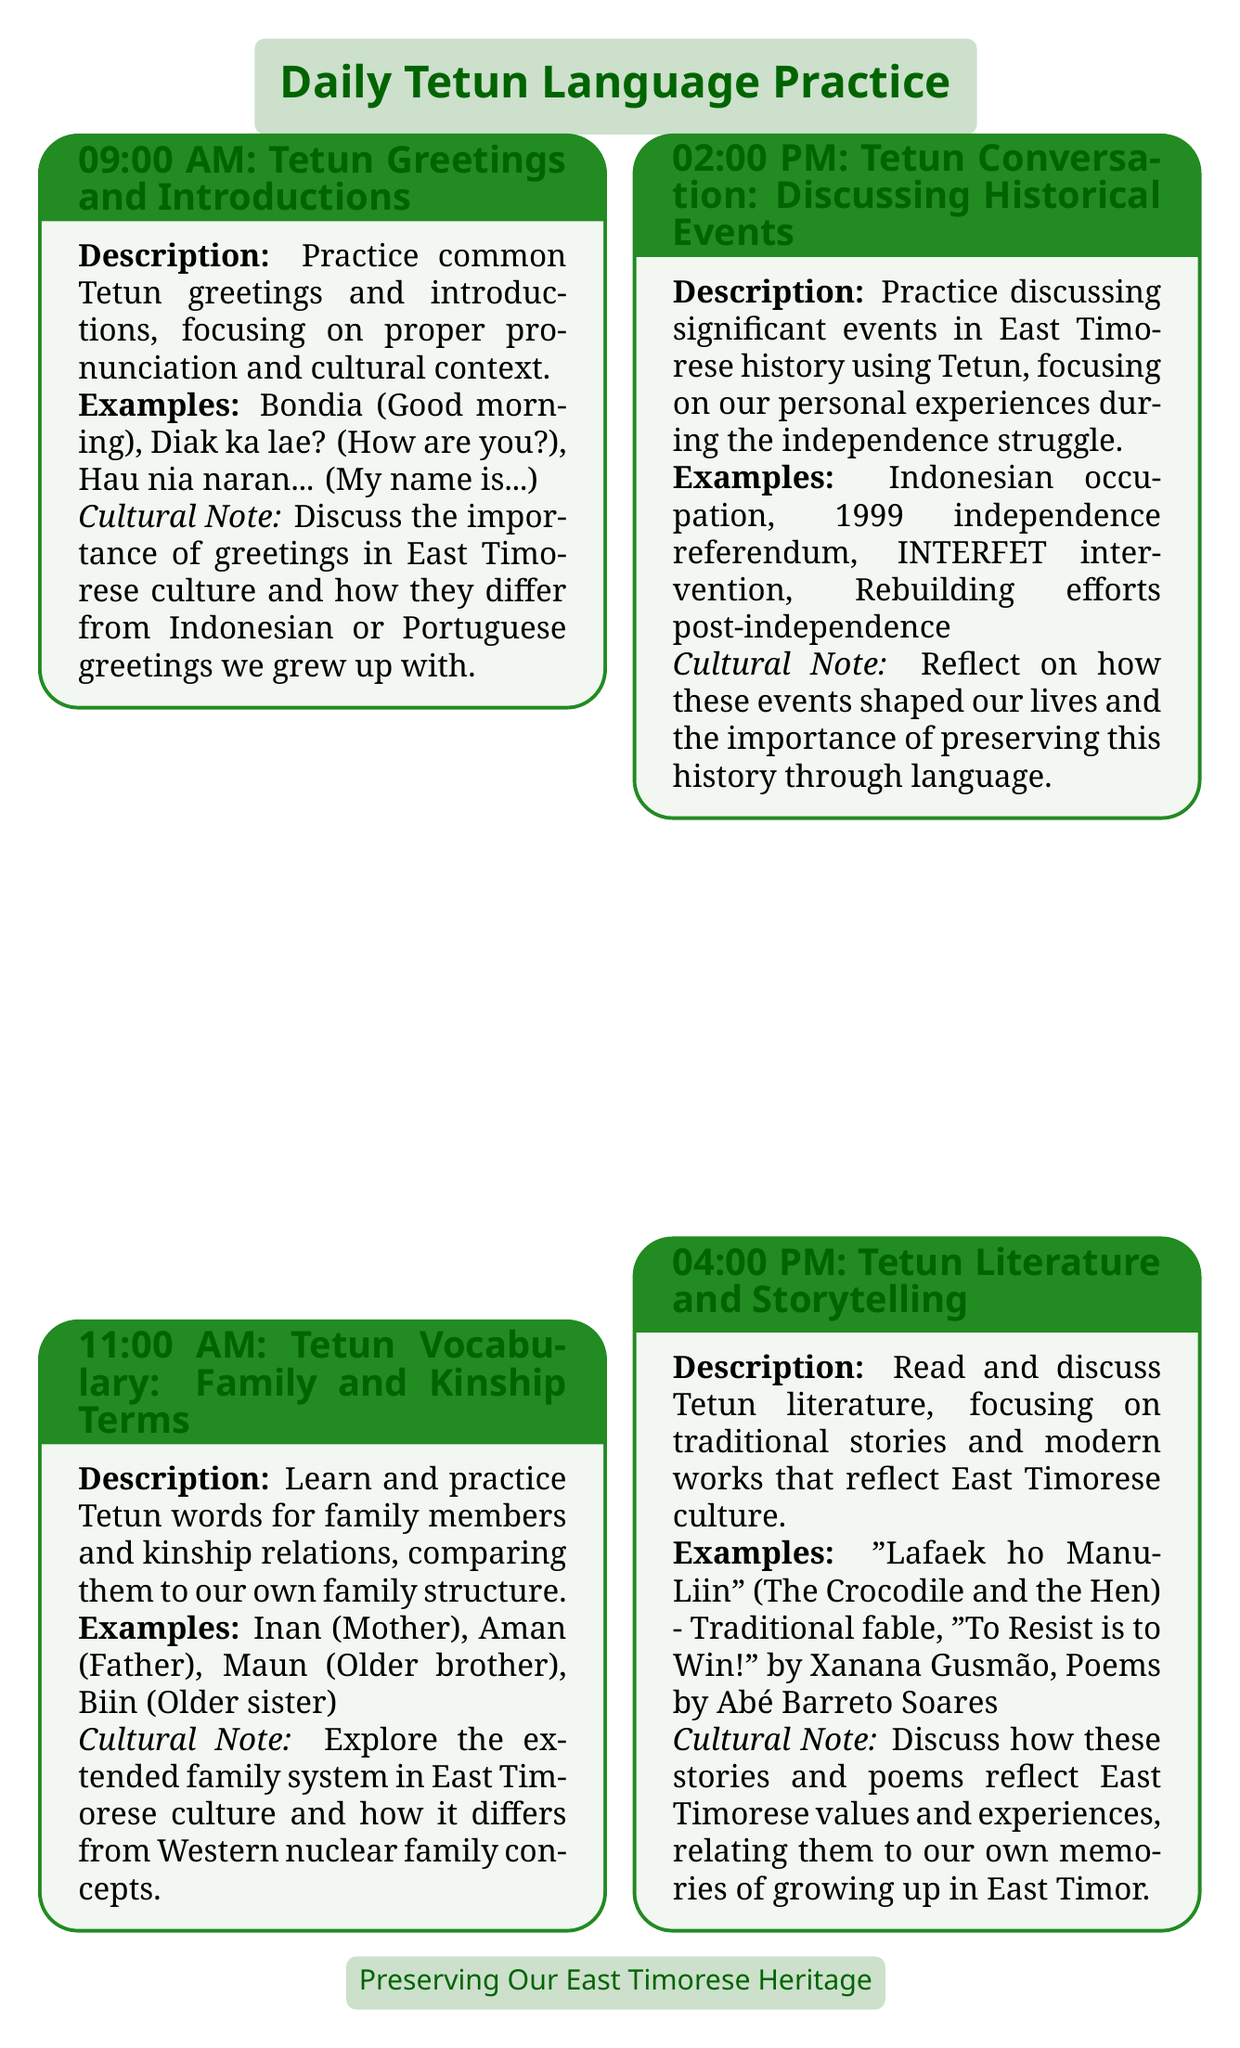What is the first activity of the day? The first activity of the day is listed as "Tetun Greetings and Introductions" at 09:00 AM.
Answer: Tetun Greetings and Introductions What time does the literature session start? The literature session is scheduled for 04:00 PM.
Answer: 04:00 PM Which family term means "Mother" in Tetun? The document provides the Tetun word for "Mother," which is included in the vocabulary section.
Answer: Inan How many daily sessions are there? The document lists a total of five daily sessions.
Answer: Five What is the focus of the session at 02:00 PM? The focus of the 02:00 PM session is on discussing significant events in East Timorese history using Tetun.
Answer: Discussing Historical Events What traditional Tetun song is mentioned? The document names the popular Tetun folk song being learned in the music session.
Answer: Kolele Mai What cultural significance is discussed during the music and dance session? The cultural significance of the songs and dances is mentioned regarding how they maintained East Timorese identity.
Answer: East Timorese identity What example work is cited from Xanana Gusmão? The document references a piece of literature authored by Xanana Gusmão in the storytelling session.
Answer: To Resist is to Win! 